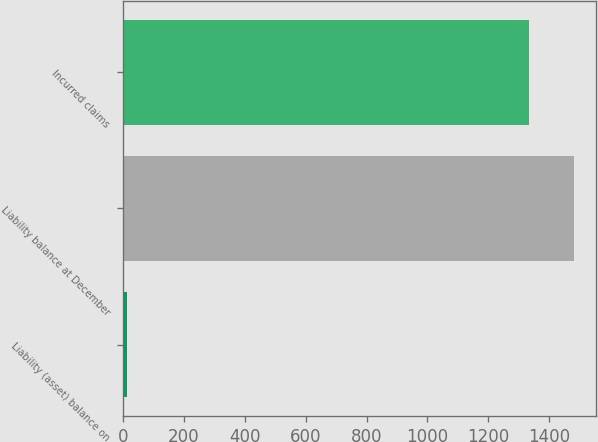Convert chart to OTSL. <chart><loc_0><loc_0><loc_500><loc_500><bar_chart><fcel>Liability (asset) balance on<fcel>Liability balance at December<fcel>Incurred claims<nl><fcel>12<fcel>1480.9<fcel>1335<nl></chart> 